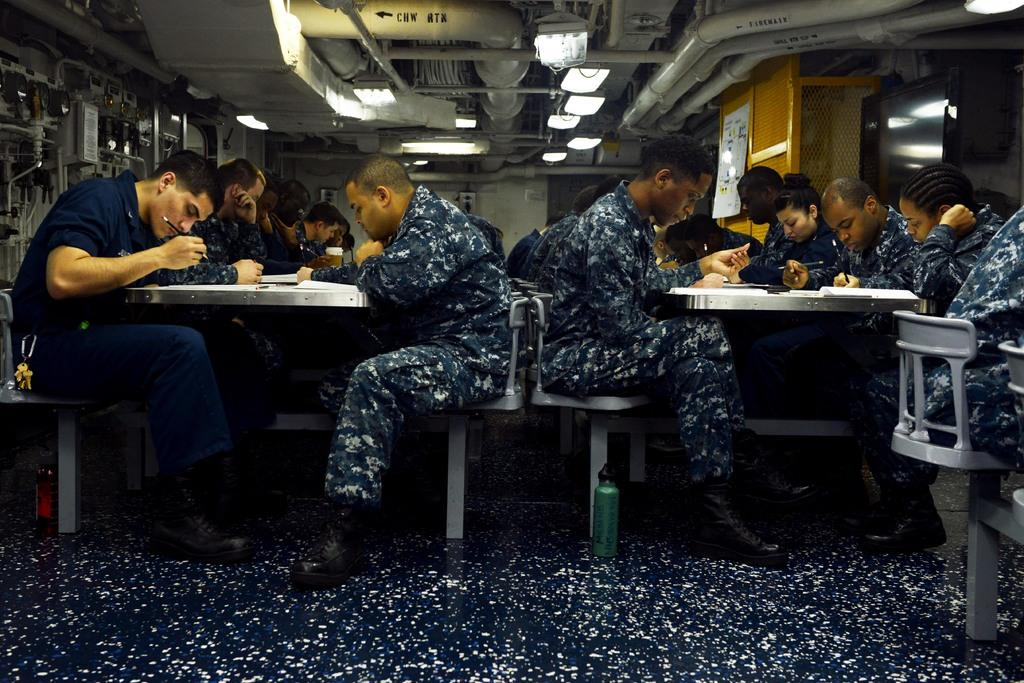What are the people in the image doing? There is a group of people sitting on chairs in the image. What objects can be seen on the table? There is a pencil, a book, and a cup on the table in the image. What can be seen illuminating the area in the image? There are lights visible in the image. What type of structure is visible in the image? There are pipes visible in the image. What is hanging on the wall in the image? There is a poster in the image. How many hands are visible in the image? There is no specific mention of hands in the provided facts, so it is not possible to determine the number of hands visible in the image. 